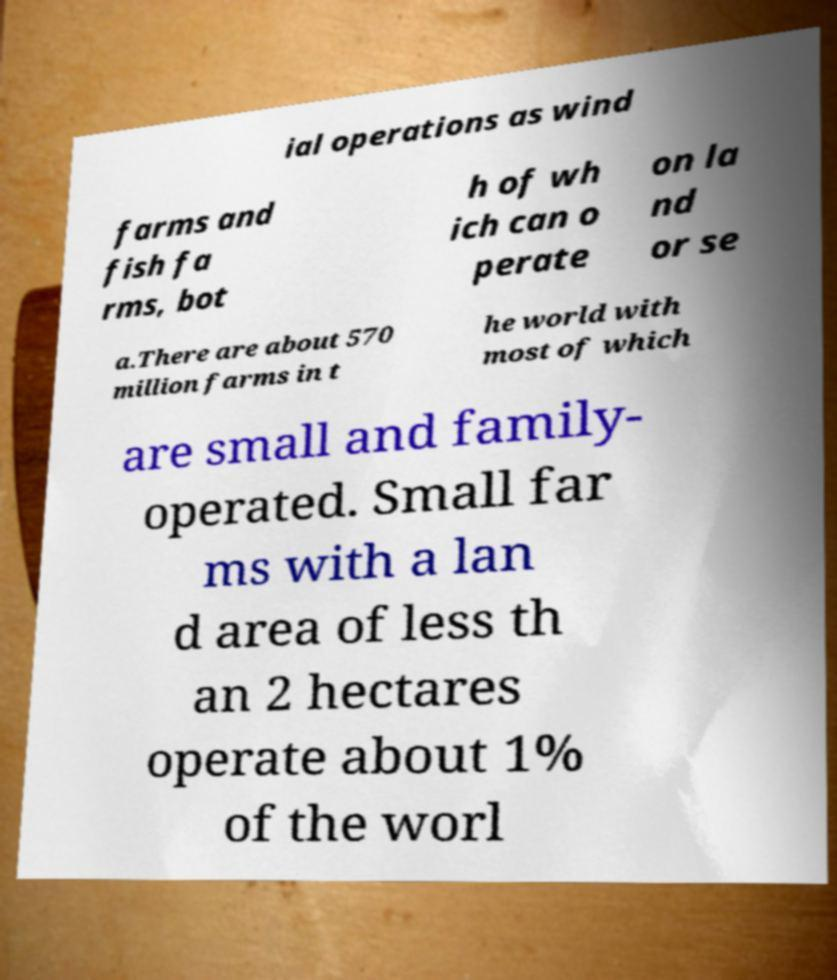Could you assist in decoding the text presented in this image and type it out clearly? ial operations as wind farms and fish fa rms, bot h of wh ich can o perate on la nd or se a.There are about 570 million farms in t he world with most of which are small and family- operated. Small far ms with a lan d area of less th an 2 hectares operate about 1% of the worl 